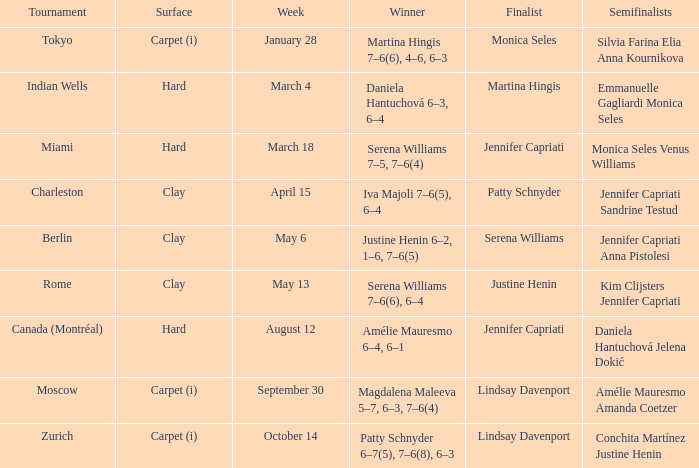What was the surface type for finalist justine henin? Clay. 